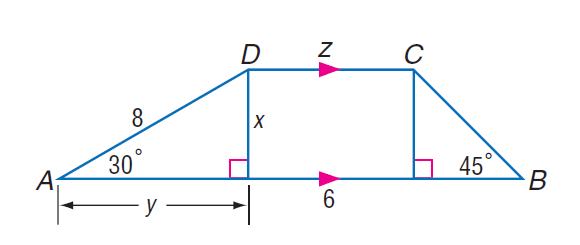Answer the mathemtical geometry problem and directly provide the correct option letter.
Question: Find x.
Choices: A: 4 B: 4 \sqrt { 3 } C: 8 D: 6 \sqrt { 3 } A 